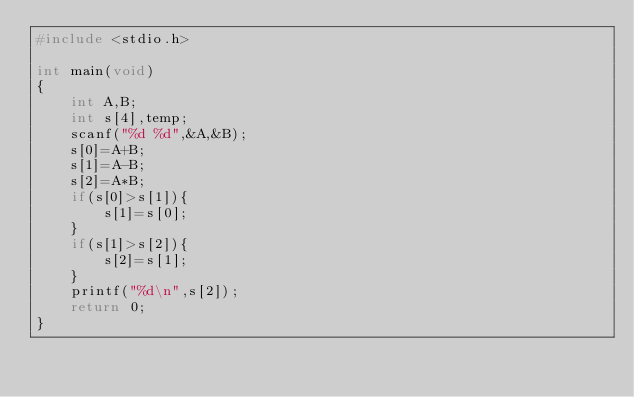Convert code to text. <code><loc_0><loc_0><loc_500><loc_500><_C_>#include <stdio.h>

int main(void)
{
	int A,B;
	int s[4],temp;
	scanf("%d %d",&A,&B);
	s[0]=A+B;
	s[1]=A-B;
	s[2]=A*B;
	if(s[0]>s[1]){
		s[1]=s[0];
	}
	if(s[1]>s[2]){
		s[2]=s[1];
	}
	printf("%d\n",s[2]);
	return 0;
}</code> 